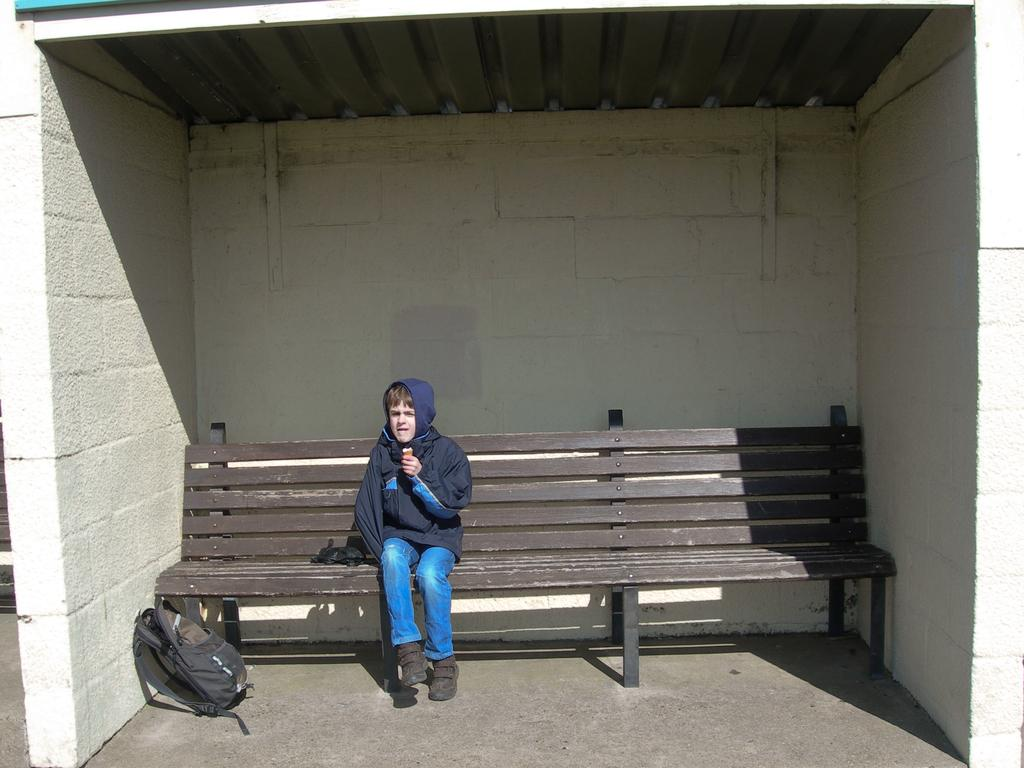What is the main structure visible in the image? There is a bus stop in the image. What is located near the bus stop? There is a bench at the bus stop. Who is sitting on the bench? A boy is sitting on the bench. What is the boy wearing? The boy is wearing a hoodie. What can be seen on the left side corner of the bench? There is a bag on the left side corner of the bench. What type of boats can be seen sailing in the air in the image? There are no boats visible in the image, and the air is not mentioned as a location for any objects. 